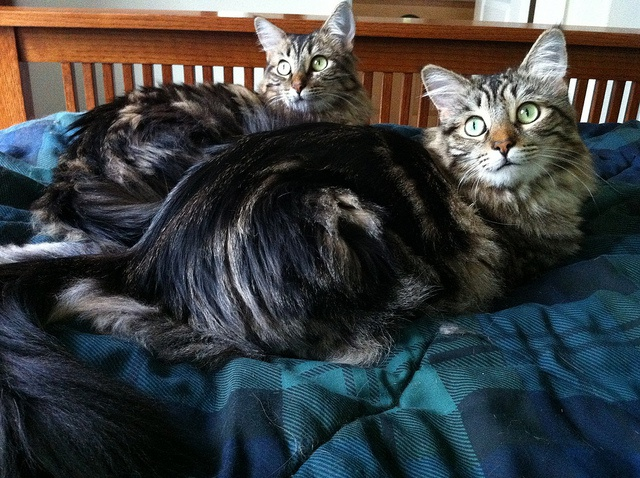Describe the objects in this image and their specific colors. I can see bed in black, darkblue, blue, and teal tones, cat in black, gray, darkgray, and lightgray tones, and cat in black, gray, darkgray, and lightgray tones in this image. 